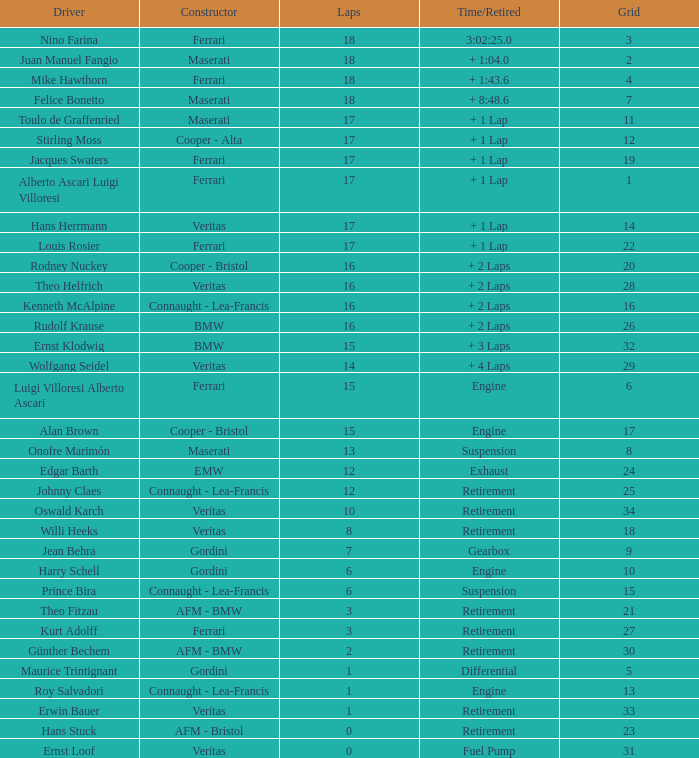Who achieved the minimum number of laps in a maserati within grid 2? 18.0. 